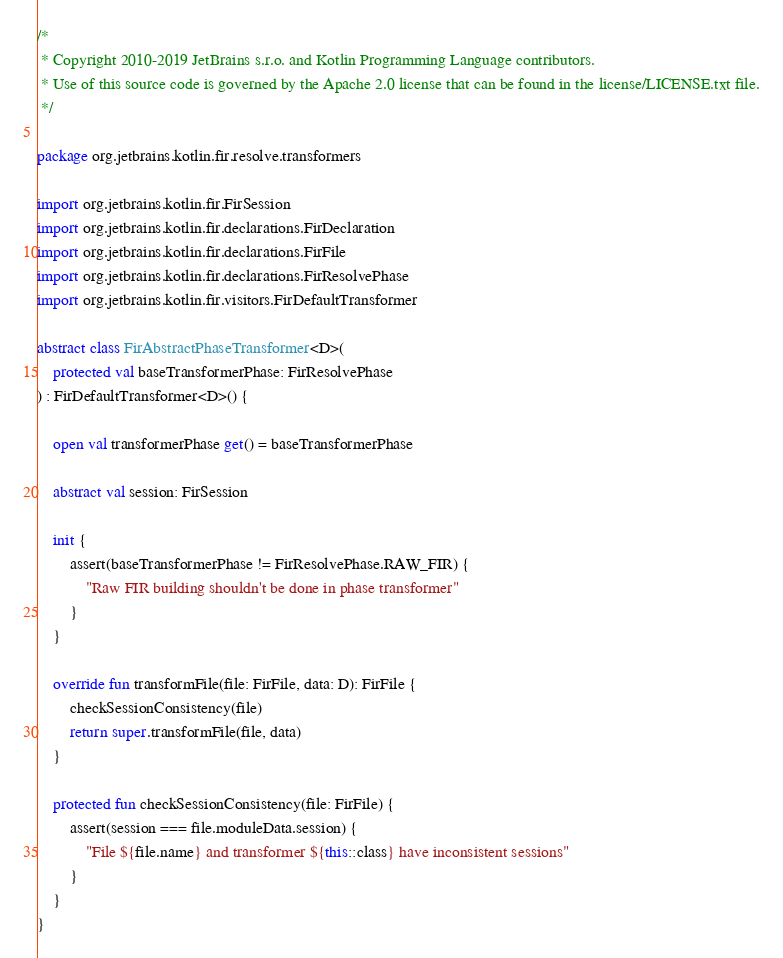<code> <loc_0><loc_0><loc_500><loc_500><_Kotlin_>/*
 * Copyright 2010-2019 JetBrains s.r.o. and Kotlin Programming Language contributors.
 * Use of this source code is governed by the Apache 2.0 license that can be found in the license/LICENSE.txt file.
 */

package org.jetbrains.kotlin.fir.resolve.transformers

import org.jetbrains.kotlin.fir.FirSession
import org.jetbrains.kotlin.fir.declarations.FirDeclaration
import org.jetbrains.kotlin.fir.declarations.FirFile
import org.jetbrains.kotlin.fir.declarations.FirResolvePhase
import org.jetbrains.kotlin.fir.visitors.FirDefaultTransformer

abstract class FirAbstractPhaseTransformer<D>(
    protected val baseTransformerPhase: FirResolvePhase
) : FirDefaultTransformer<D>() {

    open val transformerPhase get() = baseTransformerPhase

    abstract val session: FirSession

    init {
        assert(baseTransformerPhase != FirResolvePhase.RAW_FIR) {
            "Raw FIR building shouldn't be done in phase transformer"
        }
    }

    override fun transformFile(file: FirFile, data: D): FirFile {
        checkSessionConsistency(file)
        return super.transformFile(file, data)
    }

    protected fun checkSessionConsistency(file: FirFile) {
        assert(session === file.moduleData.session) {
            "File ${file.name} and transformer ${this::class} have inconsistent sessions"
        }
    }
}
</code> 